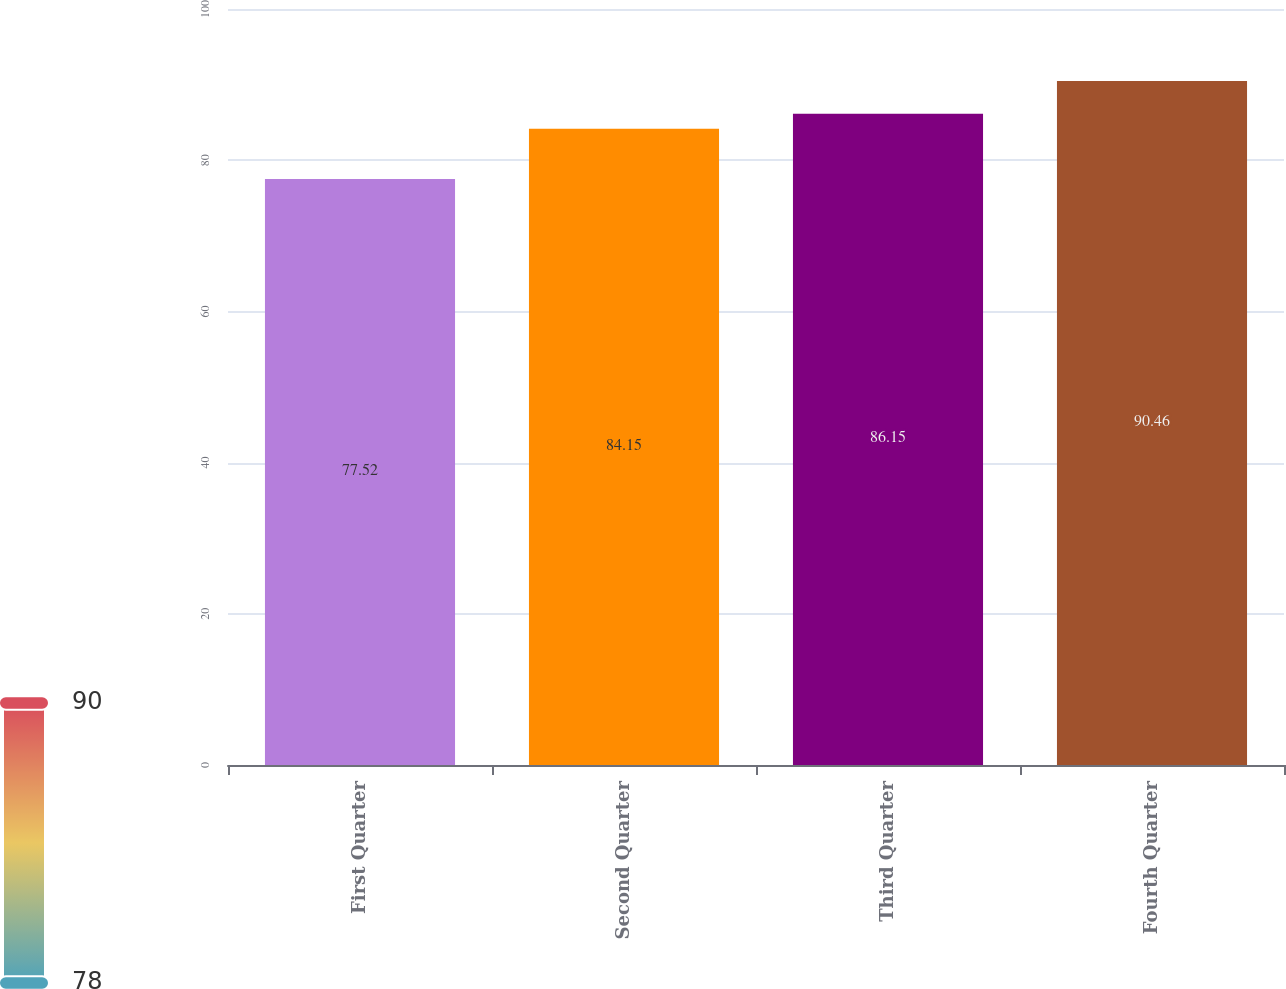<chart> <loc_0><loc_0><loc_500><loc_500><bar_chart><fcel>First Quarter<fcel>Second Quarter<fcel>Third Quarter<fcel>Fourth Quarter<nl><fcel>77.52<fcel>84.15<fcel>86.15<fcel>90.46<nl></chart> 